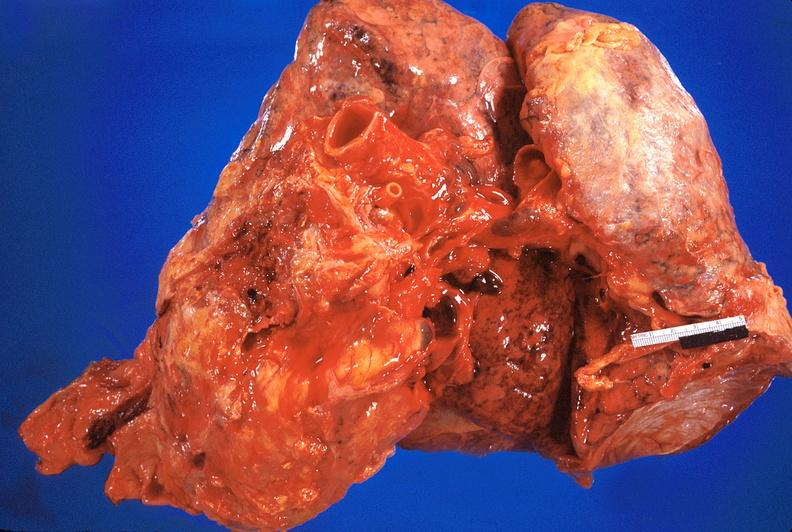what does this image show?
Answer the question using a single word or phrase. Heart and lungs 